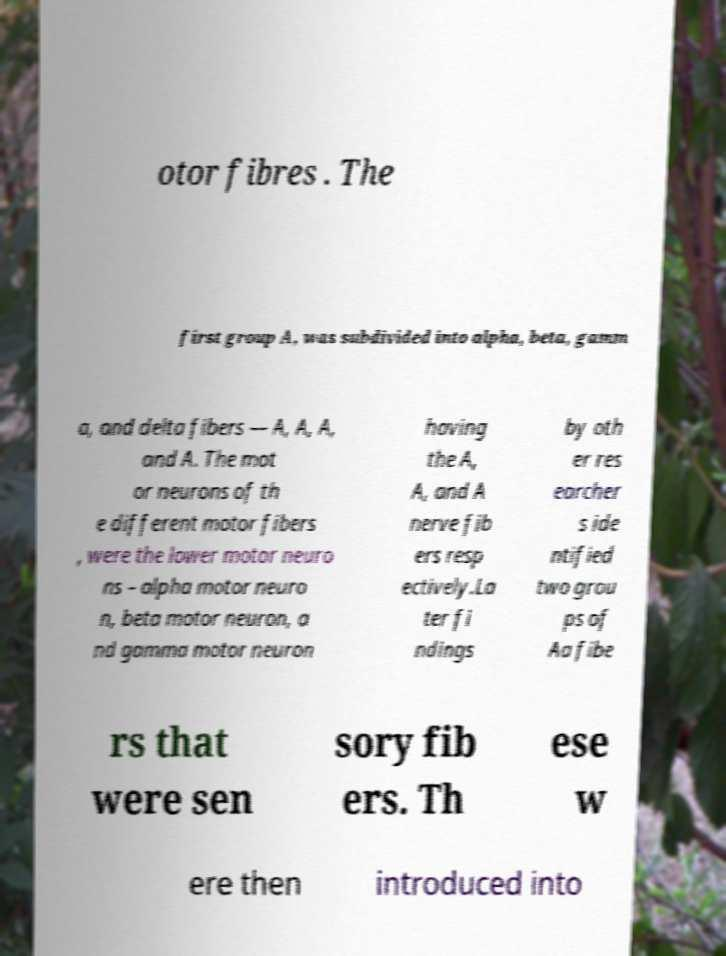There's text embedded in this image that I need extracted. Can you transcribe it verbatim? otor fibres . The first group A, was subdivided into alpha, beta, gamm a, and delta fibers — A, A, A, and A. The mot or neurons of th e different motor fibers , were the lower motor neuro ns – alpha motor neuro n, beta motor neuron, a nd gamma motor neuron having the A, A, and A nerve fib ers resp ectively.La ter fi ndings by oth er res earcher s ide ntified two grou ps of Aa fibe rs that were sen sory fib ers. Th ese w ere then introduced into 